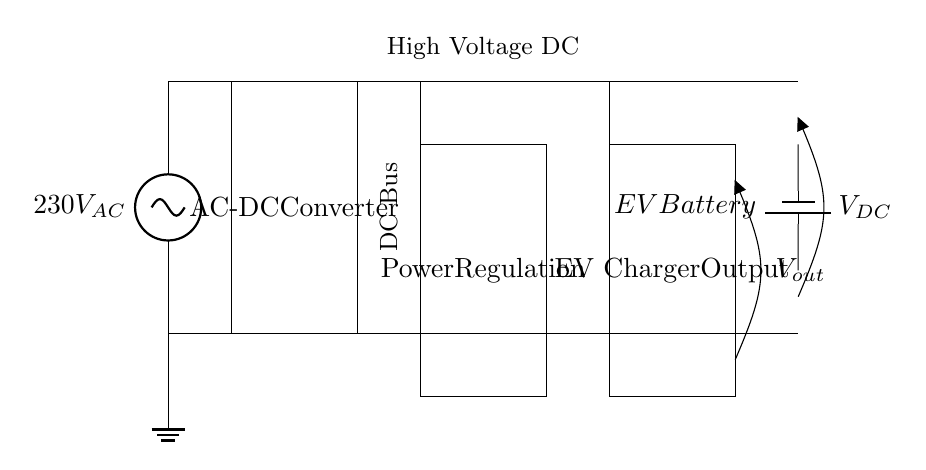What is the input voltage of the AC source? The input voltage is labeled as 230V AC in the diagram. This is indicated near the AC power source on the left.
Answer: 230V AC What is the function of the rectangle labeled "AC-DC Converter"? The rectangle represents an AC-DC Converter, which converts alternating current (AC) into direct current (DC). This function is critical for supplying the EV battery with the required power.
Answer: AC-DC Conversion How many main components are shown in the diagram? The diagram includes five main components: an AC source, AC-DC Converter, DC Bus, Power Regulation, and EV Charger Output.
Answer: Five What type of output voltage is indicated after the EV Charger? The output voltage labeled is V out, which denotes the voltage output from the EV charger. It is essential for the battery’s charging process.
Answer: V out What is the purpose of the "Power Regulation" section? The "Power Regulation" section is designed to manage and stabilize the voltage and current supplied to the EV charger and subsequently to the EV battery. This ensures that the charging process is safe and efficient.
Answer: Voltage regulation What occurs between the DC Bus and the EV Battery? The DC Bus transmits high voltage DC power to the EV Battery, facilitating charging. The DC Bus acts as an intermediary, distributing power effectively from the converter to the battery.
Answer: Charging process Which component receives the power directly from the AC-DC Converter? The component that receives power directly from the AC-DC Converter is the DC Bus, as indicated by the direct connection represented in the diagram.
Answer: DC Bus 